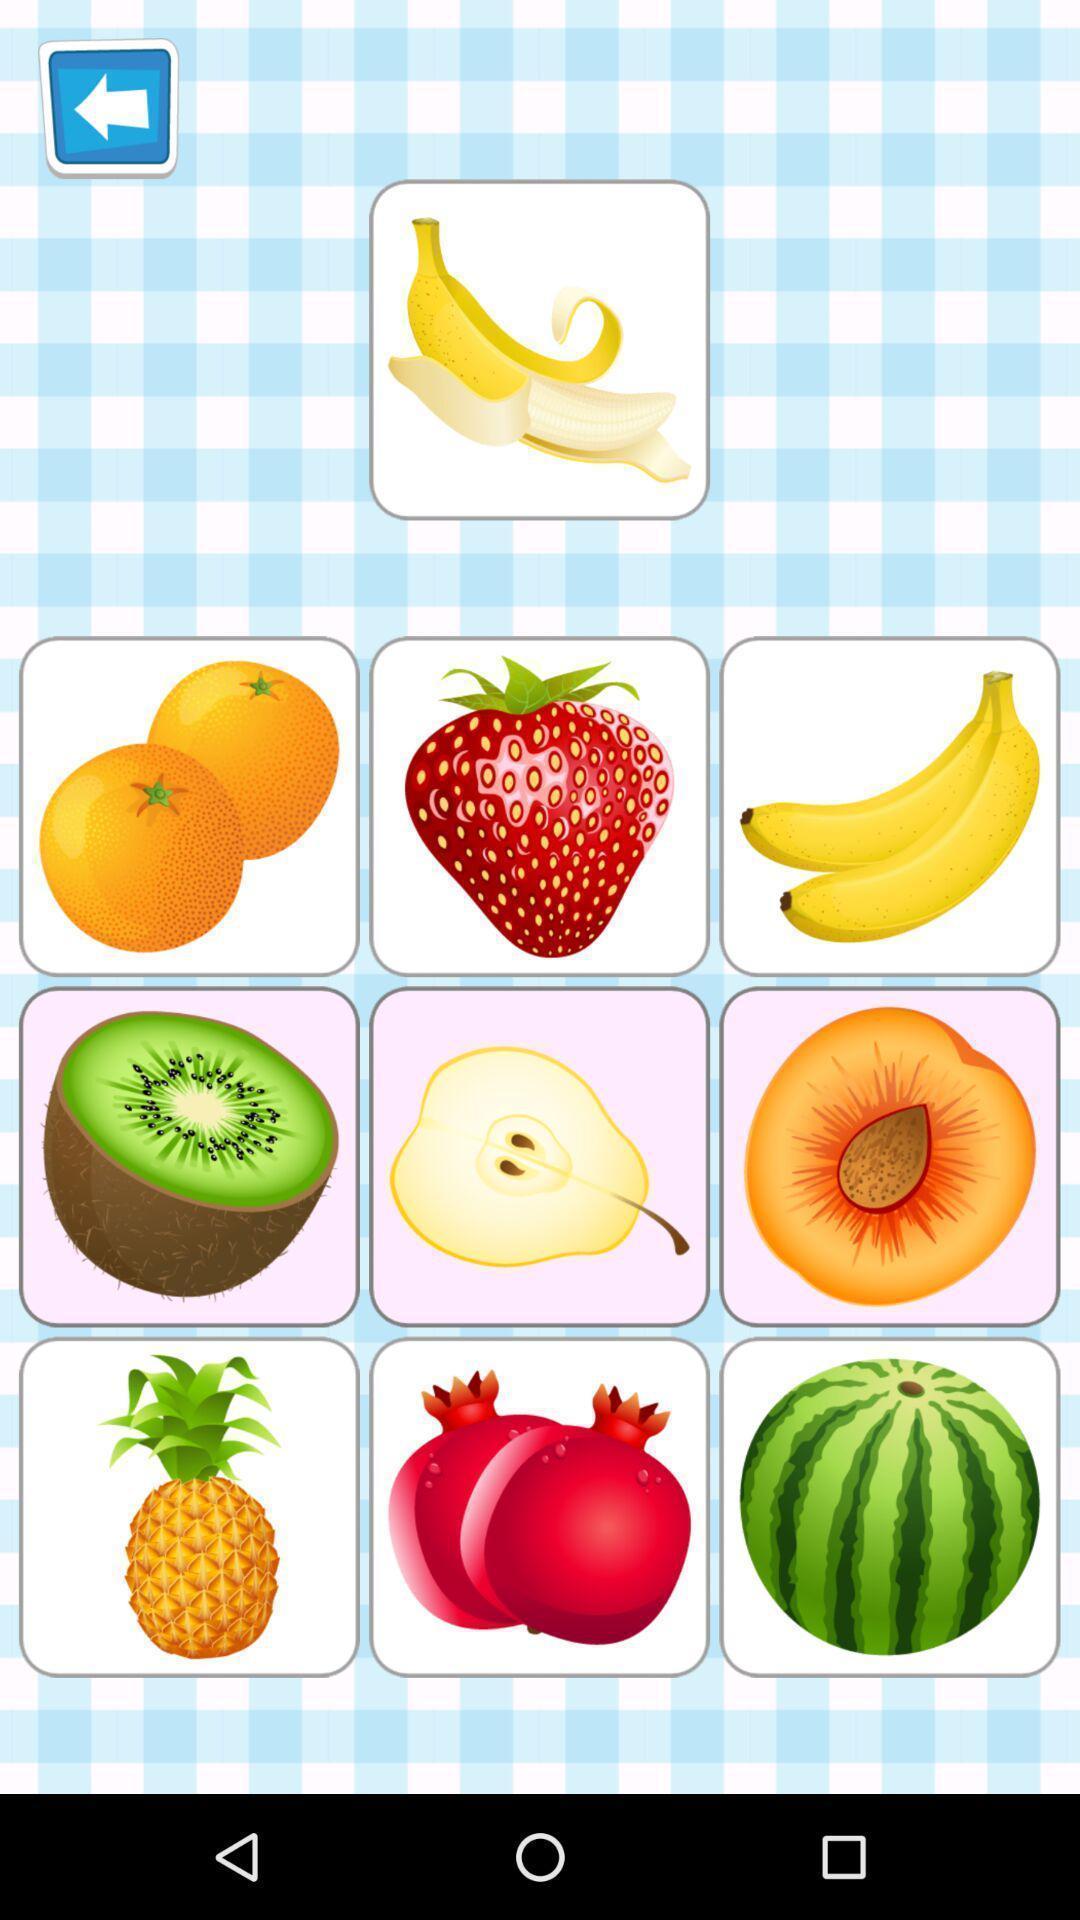Explain what's happening in this screen capture. Screen displaying the different types of fruits. 